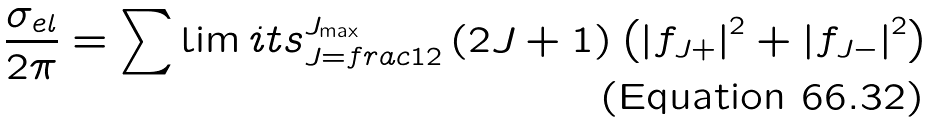<formula> <loc_0><loc_0><loc_500><loc_500>\frac { \sigma _ { e l } } { 2 \pi } = \sum \lim i t s _ { J = f r a c { 1 } { 2 } } ^ { J _ { \max } } \left ( 2 J + 1 \right ) \left ( \left | f _ { J + } \right | ^ { 2 } + \left | f _ { J - } \right | ^ { 2 } \right )</formula> 